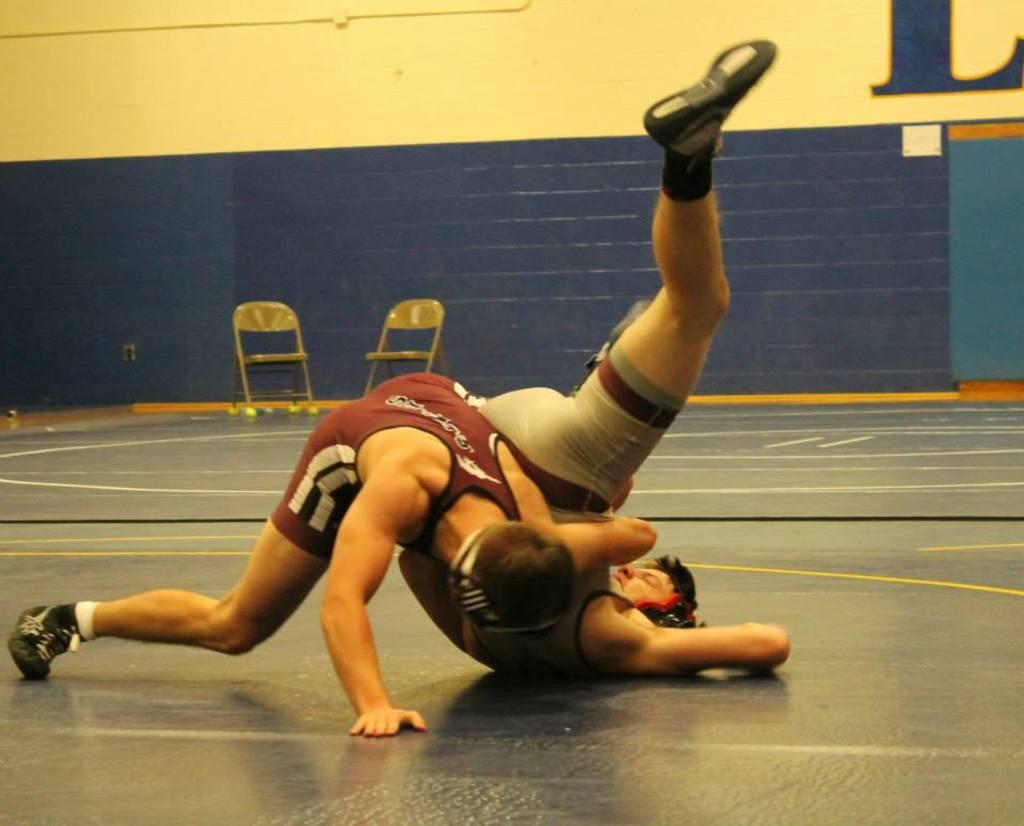How many people are present in the image? There are two people on the floor in the image. What furniture can be seen in the image? There are two chairs in the image. What color is the paint on the wall in the image? The wall in the image has blue paint. Can you see a robin wearing a scarf in the image? There is no robin or scarf present in the image. Is there a quill pen on the floor in the image? There is no quill pen visible in the image. 